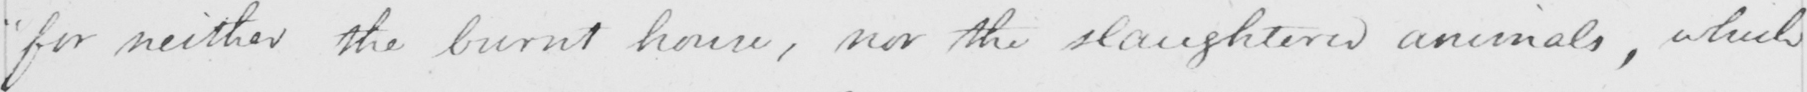Can you read and transcribe this handwriting? " for neither the burnt house , nor the slaughtered animals , which 